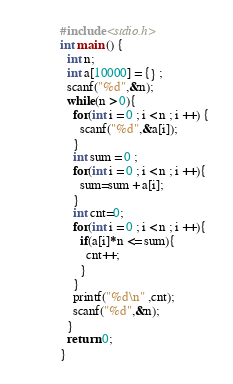Convert code to text. <code><loc_0><loc_0><loc_500><loc_500><_C_>#include <stdio.h>
int main () {
  int n;
  int a[10000] = {} ;
  scanf("%d",&n);
  while(n > 0){
    for(int i = 0 ; i < n ; i ++) {
      scanf("%d",&a[i]);
    }
    int sum = 0 ;
    for(int i = 0 ; i < n ; i ++){
      sum=sum + a[i];
    }
    int cnt=0;
    for(int i = 0 ; i < n ; i ++){
      if(a[i]*n <= sum){
        cnt++;
      }
    }
    printf("%d\n" ,cnt);
    scanf("%d",&n);
  }
  return 0;
}
</code> 